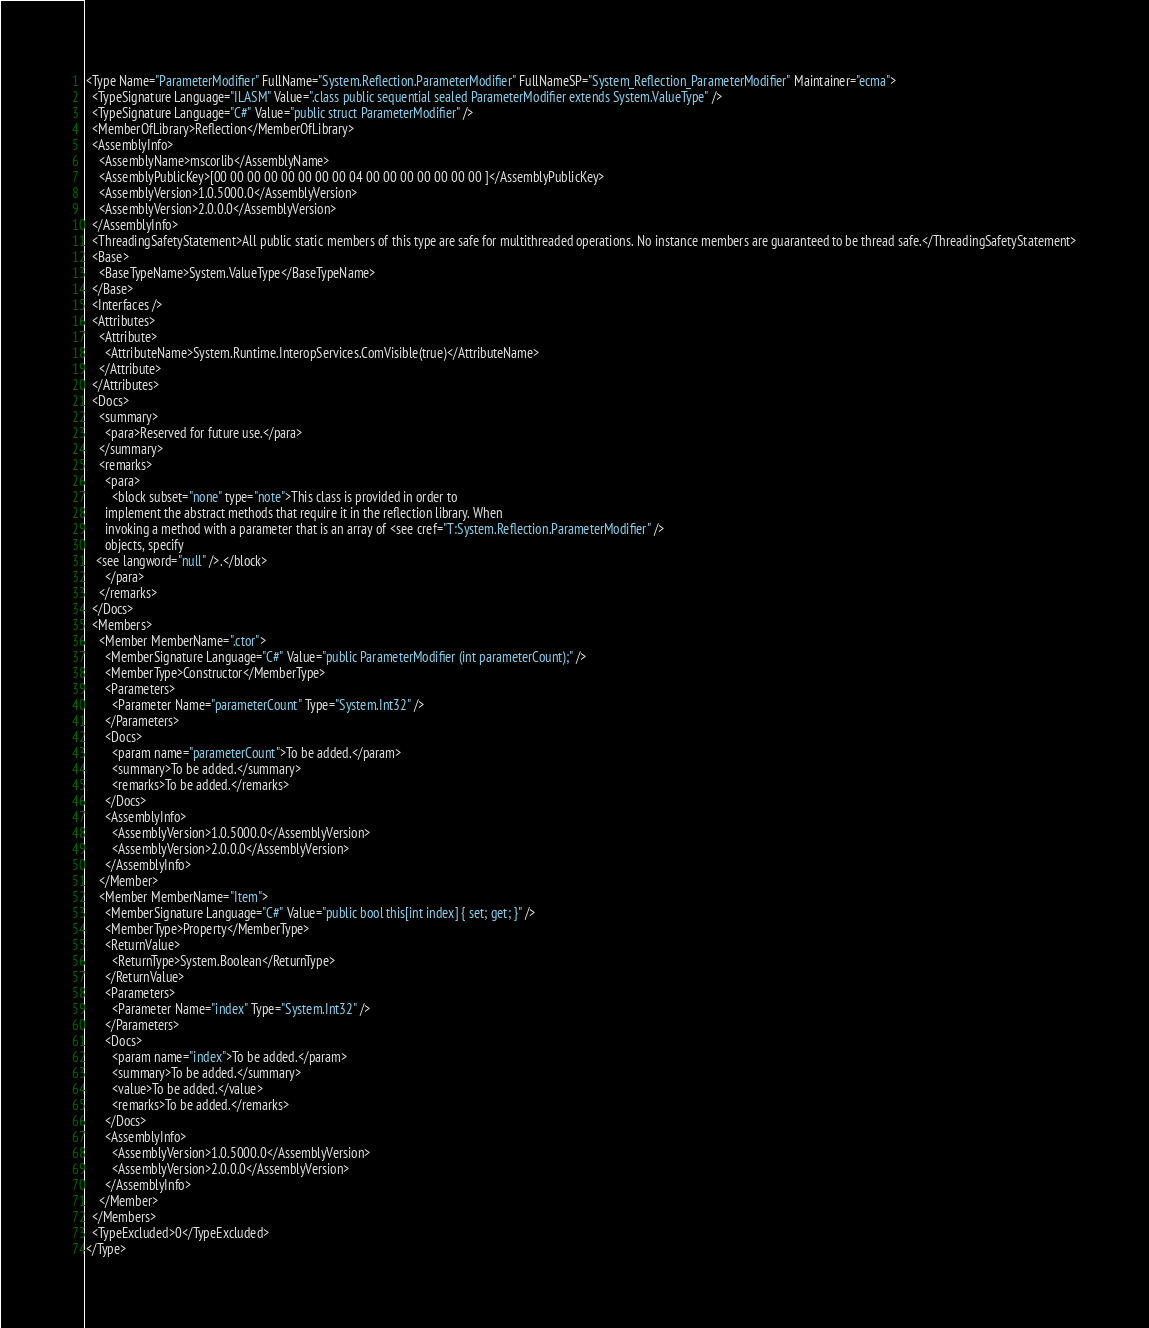Convert code to text. <code><loc_0><loc_0><loc_500><loc_500><_XML_><Type Name="ParameterModifier" FullName="System.Reflection.ParameterModifier" FullNameSP="System_Reflection_ParameterModifier" Maintainer="ecma">
  <TypeSignature Language="ILASM" Value=".class public sequential sealed ParameterModifier extends System.ValueType" />
  <TypeSignature Language="C#" Value="public struct ParameterModifier" />
  <MemberOfLibrary>Reflection</MemberOfLibrary>
  <AssemblyInfo>
    <AssemblyName>mscorlib</AssemblyName>
    <AssemblyPublicKey>[00 00 00 00 00 00 00 00 04 00 00 00 00 00 00 00 ]</AssemblyPublicKey>
    <AssemblyVersion>1.0.5000.0</AssemblyVersion>
    <AssemblyVersion>2.0.0.0</AssemblyVersion>
  </AssemblyInfo>
  <ThreadingSafetyStatement>All public static members of this type are safe for multithreaded operations. No instance members are guaranteed to be thread safe.</ThreadingSafetyStatement>
  <Base>
    <BaseTypeName>System.ValueType</BaseTypeName>
  </Base>
  <Interfaces />
  <Attributes>
    <Attribute>
      <AttributeName>System.Runtime.InteropServices.ComVisible(true)</AttributeName>
    </Attribute>
  </Attributes>
  <Docs>
    <summary>
      <para>Reserved for future use.</para>
    </summary>
    <remarks>
      <para>
        <block subset="none" type="note">This class is provided in order to
      implement the abstract methods that require it in the reflection library. When
      invoking a method with a parameter that is an array of <see cref="T:System.Reflection.ParameterModifier" />
      objects, specify
   <see langword="null" />.</block>
      </para>
    </remarks>
  </Docs>
  <Members>
    <Member MemberName=".ctor">
      <MemberSignature Language="C#" Value="public ParameterModifier (int parameterCount);" />
      <MemberType>Constructor</MemberType>
      <Parameters>
        <Parameter Name="parameterCount" Type="System.Int32" />
      </Parameters>
      <Docs>
        <param name="parameterCount">To be added.</param>
        <summary>To be added.</summary>
        <remarks>To be added.</remarks>
      </Docs>
      <AssemblyInfo>
        <AssemblyVersion>1.0.5000.0</AssemblyVersion>
        <AssemblyVersion>2.0.0.0</AssemblyVersion>
      </AssemblyInfo>
    </Member>
    <Member MemberName="Item">
      <MemberSignature Language="C#" Value="public bool this[int index] { set; get; }" />
      <MemberType>Property</MemberType>
      <ReturnValue>
        <ReturnType>System.Boolean</ReturnType>
      </ReturnValue>
      <Parameters>
        <Parameter Name="index" Type="System.Int32" />
      </Parameters>
      <Docs>
        <param name="index">To be added.</param>
        <summary>To be added.</summary>
        <value>To be added.</value>
        <remarks>To be added.</remarks>
      </Docs>
      <AssemblyInfo>
        <AssemblyVersion>1.0.5000.0</AssemblyVersion>
        <AssemblyVersion>2.0.0.0</AssemblyVersion>
      </AssemblyInfo>
    </Member>
  </Members>
  <TypeExcluded>0</TypeExcluded>
</Type>
</code> 